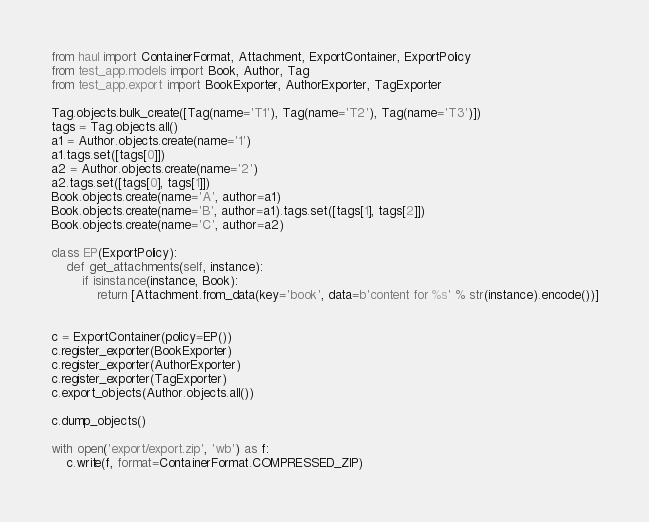Convert code to text. <code><loc_0><loc_0><loc_500><loc_500><_Python_>from haul import ContainerFormat, Attachment, ExportContainer, ExportPolicy
from test_app.models import Book, Author, Tag
from test_app.export import BookExporter, AuthorExporter, TagExporter

Tag.objects.bulk_create([Tag(name='T1'), Tag(name='T2'), Tag(name='T3')])
tags = Tag.objects.all()
a1 = Author.objects.create(name='1')
a1.tags.set([tags[0]])
a2 = Author.objects.create(name='2')
a2.tags.set([tags[0], tags[1]])
Book.objects.create(name='A', author=a1)
Book.objects.create(name='B', author=a1).tags.set([tags[1], tags[2]])
Book.objects.create(name='C', author=a2)

class EP(ExportPolicy):
    def get_attachments(self, instance):
        if isinstance(instance, Book):
            return [Attachment.from_data(key='book', data=b'content for %s' % str(instance).encode())]


c = ExportContainer(policy=EP())
c.register_exporter(BookExporter)
c.register_exporter(AuthorExporter)
c.register_exporter(TagExporter)
c.export_objects(Author.objects.all())

c.dump_objects()

with open('export/export.zip', 'wb') as f:
    c.write(f, format=ContainerFormat.COMPRESSED_ZIP)
</code> 